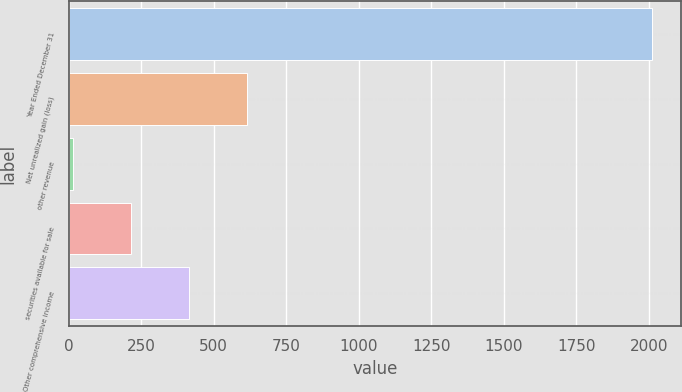Convert chart. <chart><loc_0><loc_0><loc_500><loc_500><bar_chart><fcel>Year Ended December 31<fcel>Net unrealized gain (loss)<fcel>other revenue<fcel>securities available for sale<fcel>Other comprehensive income<nl><fcel>2012<fcel>613.4<fcel>14<fcel>213.8<fcel>413.6<nl></chart> 